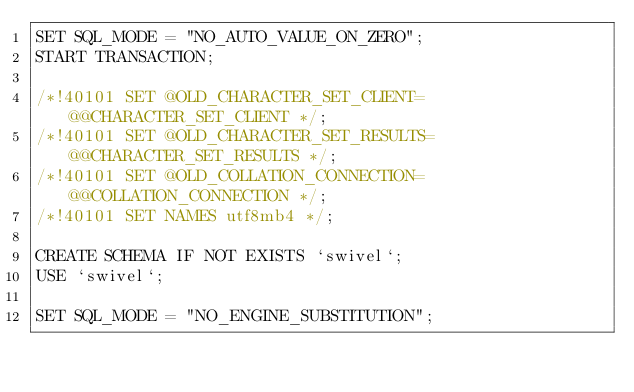Convert code to text. <code><loc_0><loc_0><loc_500><loc_500><_SQL_>SET SQL_MODE = "NO_AUTO_VALUE_ON_ZERO";
START TRANSACTION;

/*!40101 SET @OLD_CHARACTER_SET_CLIENT=@@CHARACTER_SET_CLIENT */;
/*!40101 SET @OLD_CHARACTER_SET_RESULTS=@@CHARACTER_SET_RESULTS */;
/*!40101 SET @OLD_COLLATION_CONNECTION=@@COLLATION_CONNECTION */;
/*!40101 SET NAMES utf8mb4 */;

CREATE SCHEMA IF NOT EXISTS `swivel`;
USE `swivel`;

SET SQL_MODE = "NO_ENGINE_SUBSTITUTION";</code> 